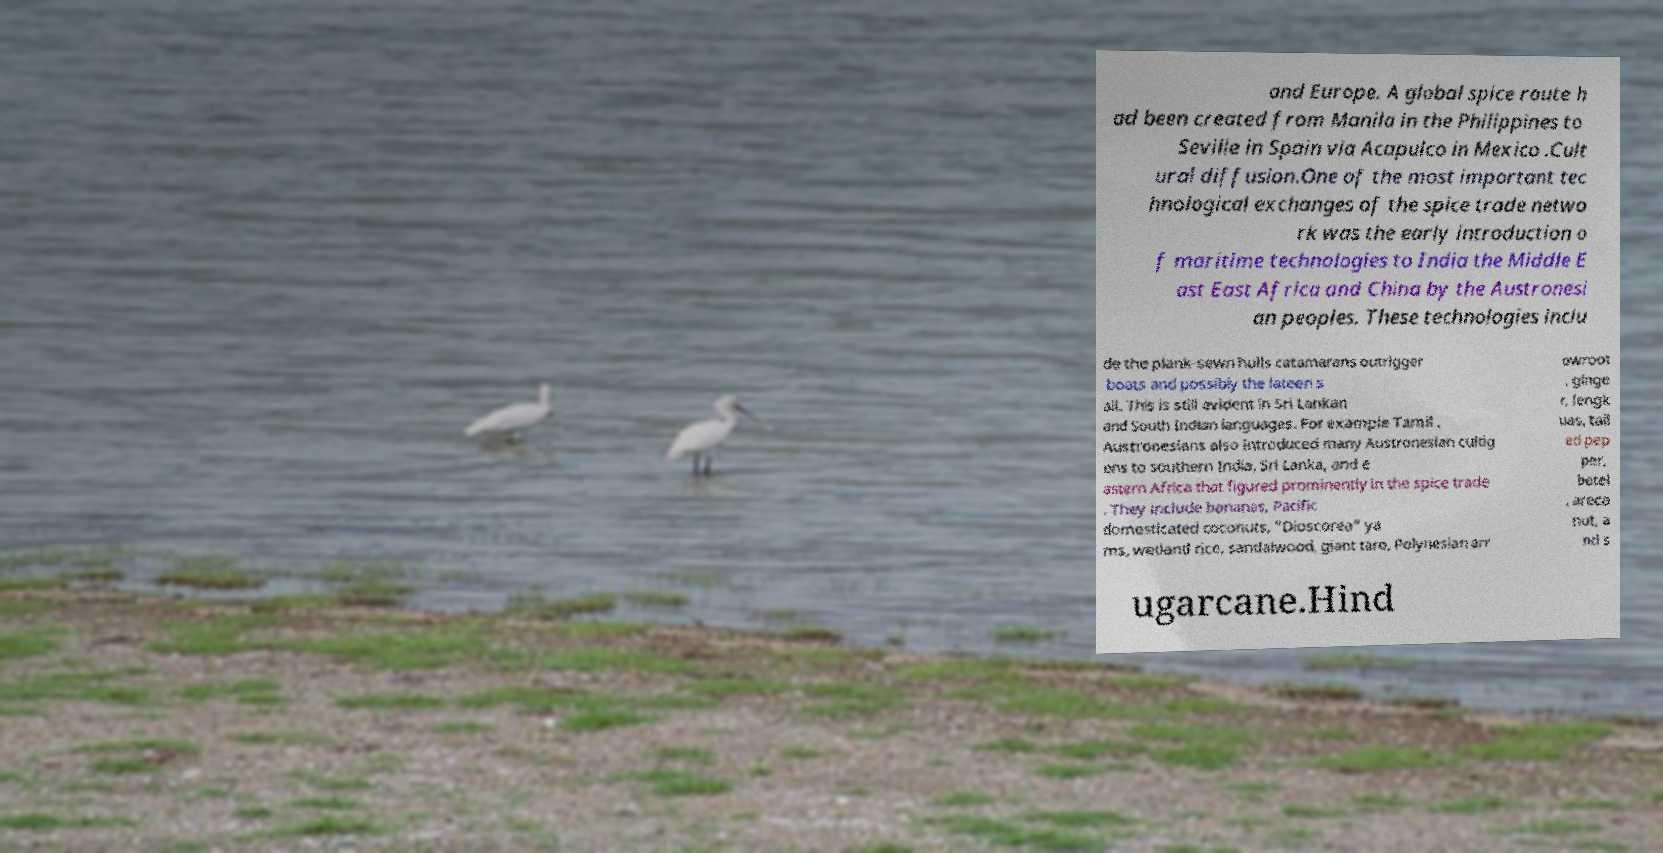Can you read and provide the text displayed in the image?This photo seems to have some interesting text. Can you extract and type it out for me? and Europe. A global spice route h ad been created from Manila in the Philippines to Seville in Spain via Acapulco in Mexico .Cult ural diffusion.One of the most important tec hnological exchanges of the spice trade netwo rk was the early introduction o f maritime technologies to India the Middle E ast East Africa and China by the Austronesi an peoples. These technologies inclu de the plank-sewn hulls catamarans outrigger boats and possibly the lateen s ail. This is still evident in Sri Lankan and South Indian languages. For example Tamil . Austronesians also introduced many Austronesian cultig ens to southern India, Sri Lanka, and e astern Africa that figured prominently in the spice trade . They include bananas, Pacific domesticated coconuts, "Dioscorea" ya ms, wetland rice, sandalwood, giant taro, Polynesian arr owroot , ginge r, lengk uas, tail ed pep per, betel , areca nut, a nd s ugarcane.Hind 